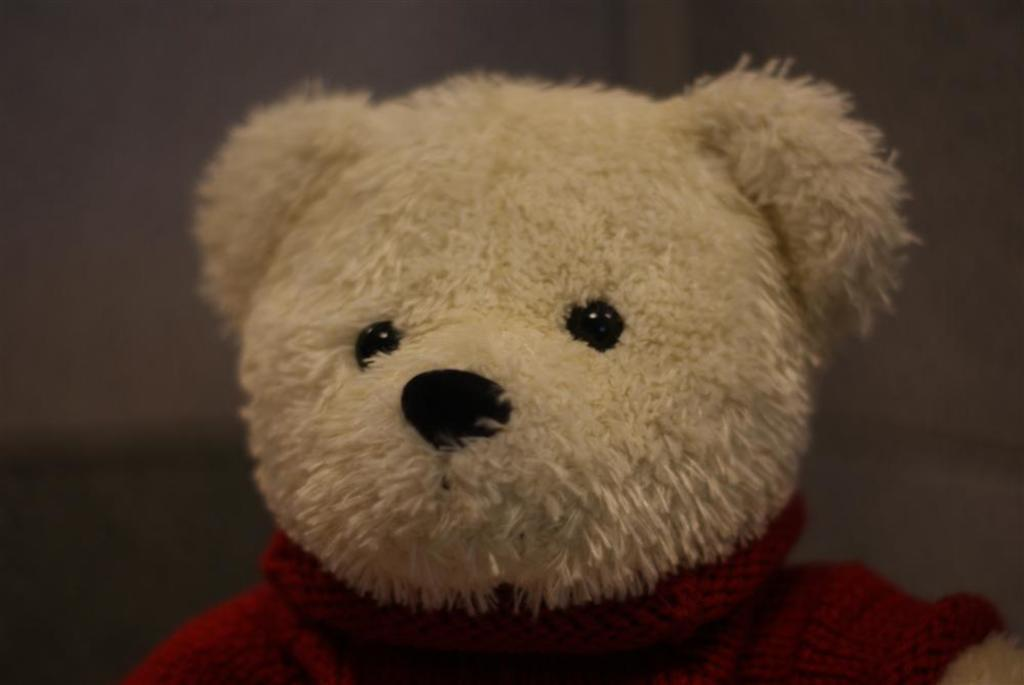What type of toy is present in the image? There is a white teddy bear in the image. Can you describe the color of the teddy bear? The teddy bear is white. Is the teddy bear wearing a hat in the image? No, the teddy bear is not wearing a hat in the image. What type of support is the teddy bear providing in the image? The teddy bear is not providing any support in the image; it is a stationary toy. 